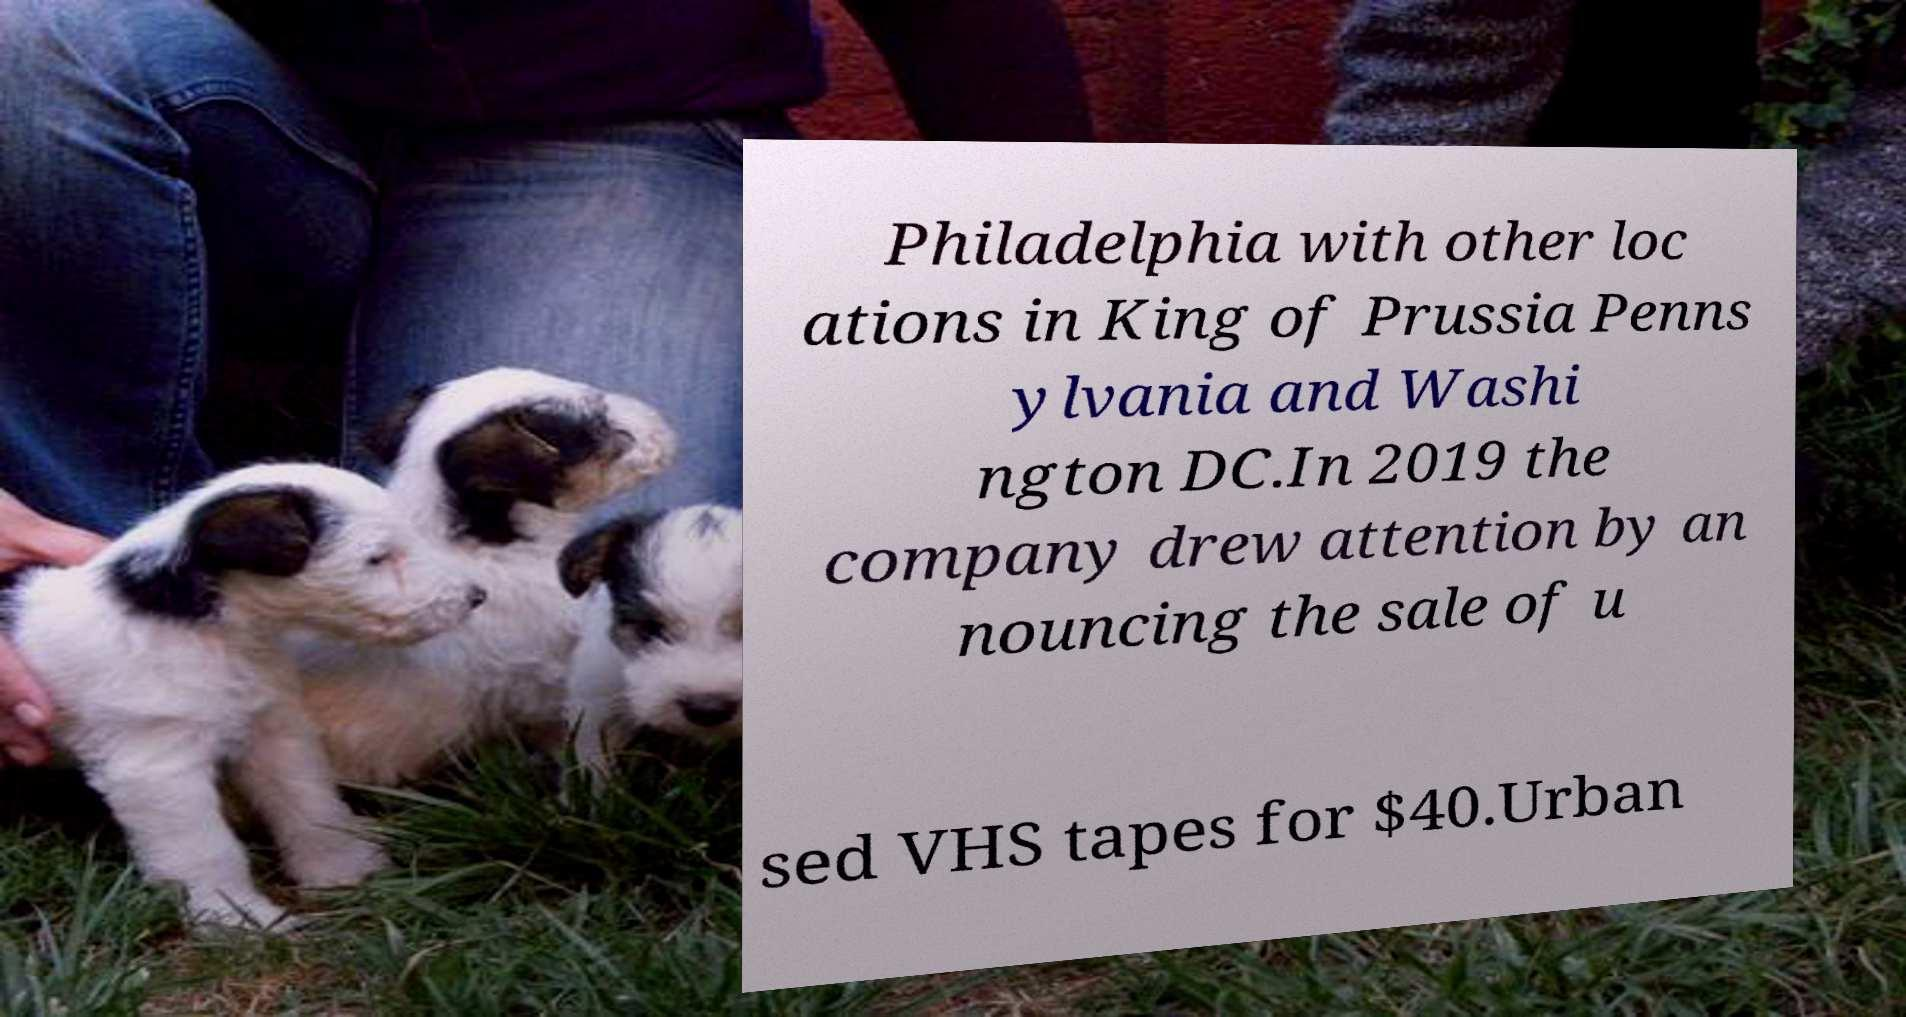Could you assist in decoding the text presented in this image and type it out clearly? Philadelphia with other loc ations in King of Prussia Penns ylvania and Washi ngton DC.In 2019 the company drew attention by an nouncing the sale of u sed VHS tapes for $40.Urban 